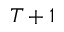<formula> <loc_0><loc_0><loc_500><loc_500>T + 1</formula> 